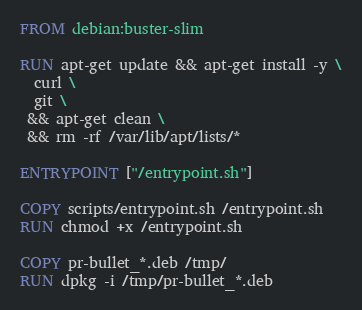Convert code to text. <code><loc_0><loc_0><loc_500><loc_500><_Dockerfile_>FROM debian:buster-slim

RUN apt-get update && apt-get install -y \
  curl \
  git \
 && apt-get clean \
 && rm -rf /var/lib/apt/lists/*

ENTRYPOINT ["/entrypoint.sh"]

COPY scripts/entrypoint.sh /entrypoint.sh
RUN chmod +x /entrypoint.sh

COPY pr-bullet_*.deb /tmp/
RUN dpkg -i /tmp/pr-bullet_*.deb
</code> 